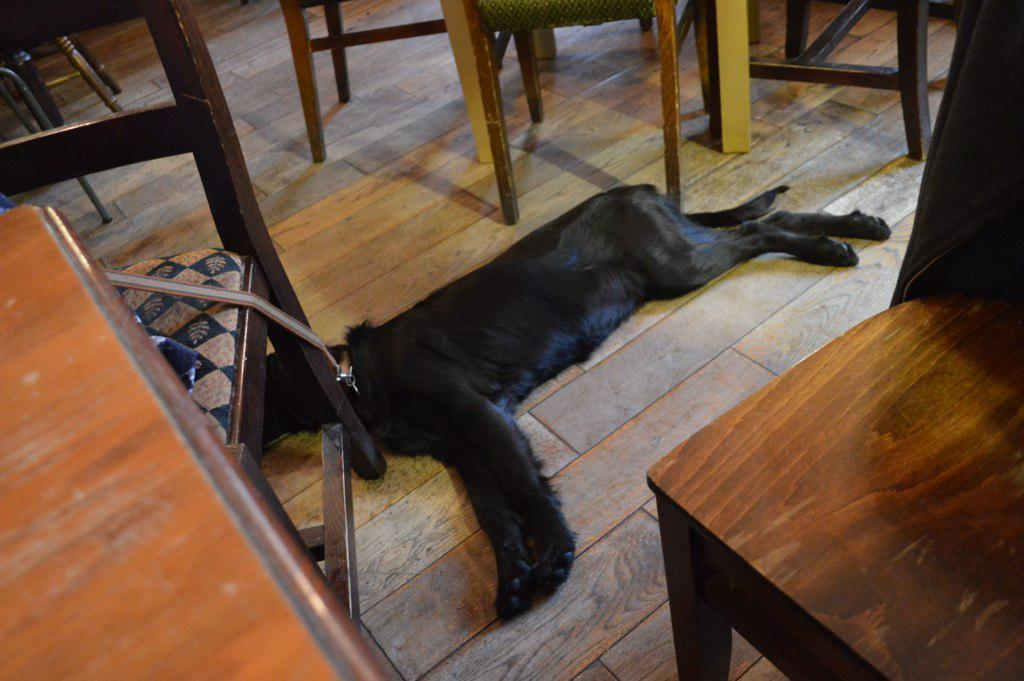What is the main subject in the center of the image? There is a dog in the center of the image. What type of furniture is present around the dog? Tables and chairs are present around the dog. What type of plants can be seen growing on the dog's coat in the image? There are no plants visible on the dog's coat in the image. 